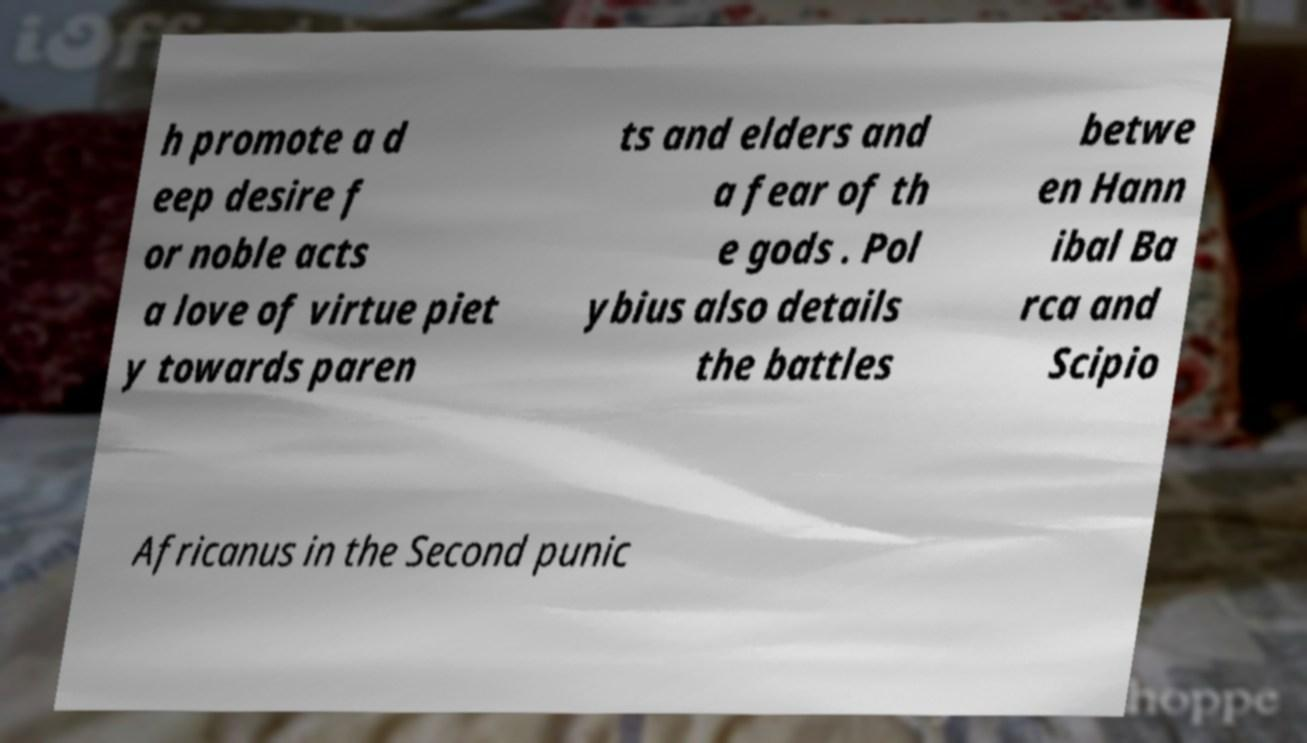For documentation purposes, I need the text within this image transcribed. Could you provide that? h promote a d eep desire f or noble acts a love of virtue piet y towards paren ts and elders and a fear of th e gods . Pol ybius also details the battles betwe en Hann ibal Ba rca and Scipio Africanus in the Second punic 